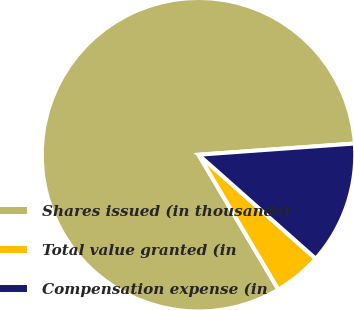Convert chart to OTSL. <chart><loc_0><loc_0><loc_500><loc_500><pie_chart><fcel>Shares issued (in thousands)<fcel>Total value granted (in<fcel>Compensation expense (in<nl><fcel>82.37%<fcel>4.94%<fcel>12.69%<nl></chart> 